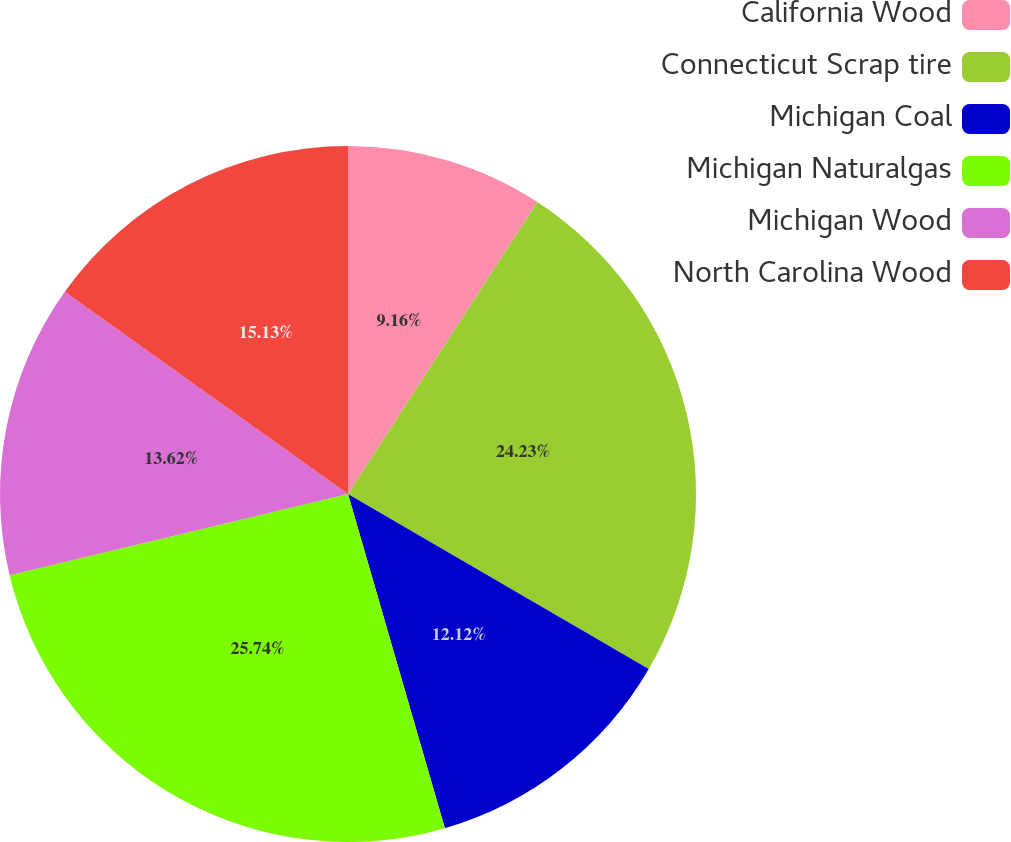Convert chart. <chart><loc_0><loc_0><loc_500><loc_500><pie_chart><fcel>California Wood<fcel>Connecticut Scrap tire<fcel>Michigan Coal<fcel>Michigan Naturalgas<fcel>Michigan Wood<fcel>North Carolina Wood<nl><fcel>9.16%<fcel>24.23%<fcel>12.12%<fcel>25.74%<fcel>13.62%<fcel>15.13%<nl></chart> 